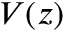Convert formula to latex. <formula><loc_0><loc_0><loc_500><loc_500>V ( z )</formula> 